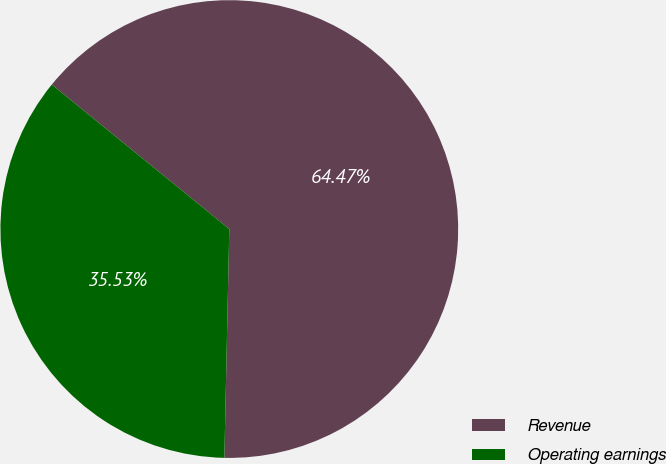Convert chart. <chart><loc_0><loc_0><loc_500><loc_500><pie_chart><fcel>Revenue<fcel>Operating earnings<nl><fcel>64.47%<fcel>35.53%<nl></chart> 